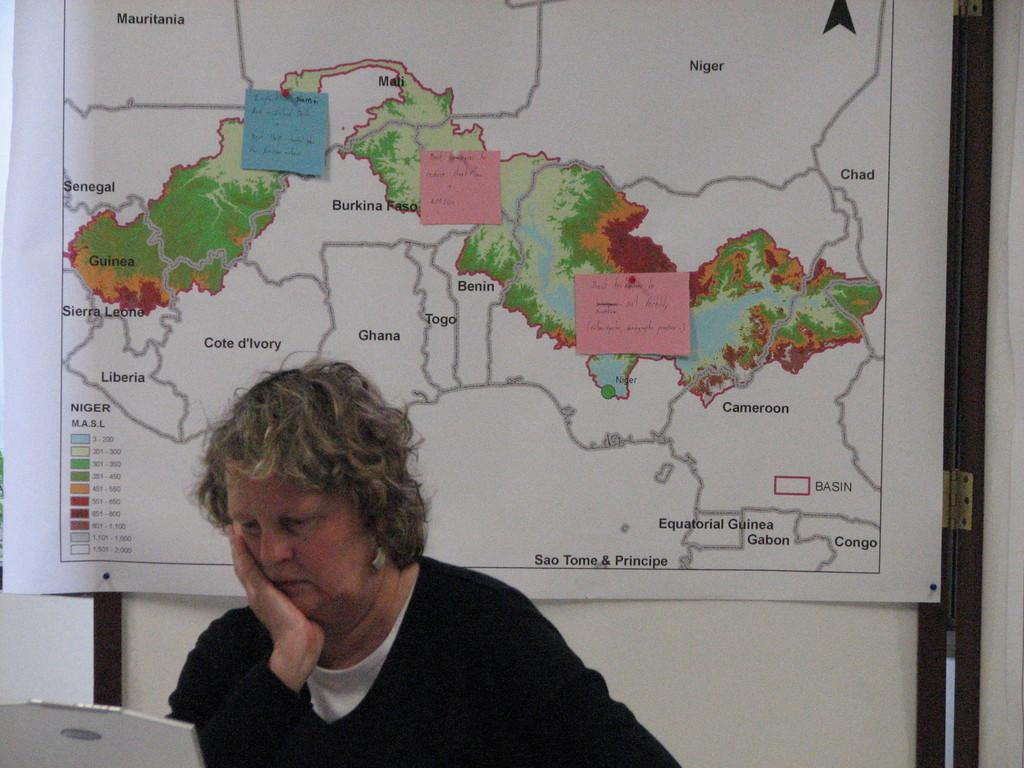Who is present in the image? There is a woman in the image. What object can be seen in the image? There is a map in the image. Where is the map located in the image? The map is kept in front of a wall. What type of badge is the woman wearing in the image? There is no badge visible on the woman in the image. What question is being asked on the map in the image? The map does not contain any questions; it is a visual representation of geographical information. 